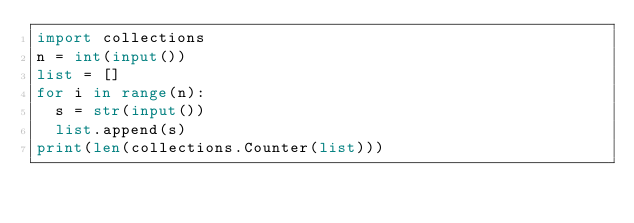Convert code to text. <code><loc_0><loc_0><loc_500><loc_500><_Python_>import collections
n = int(input())
list = []
for i in range(n):
  s = str(input())
  list.append(s)
print(len(collections.Counter(list)))</code> 